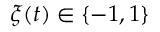Convert formula to latex. <formula><loc_0><loc_0><loc_500><loc_500>\xi ( t ) \in \{ - 1 , 1 \}</formula> 